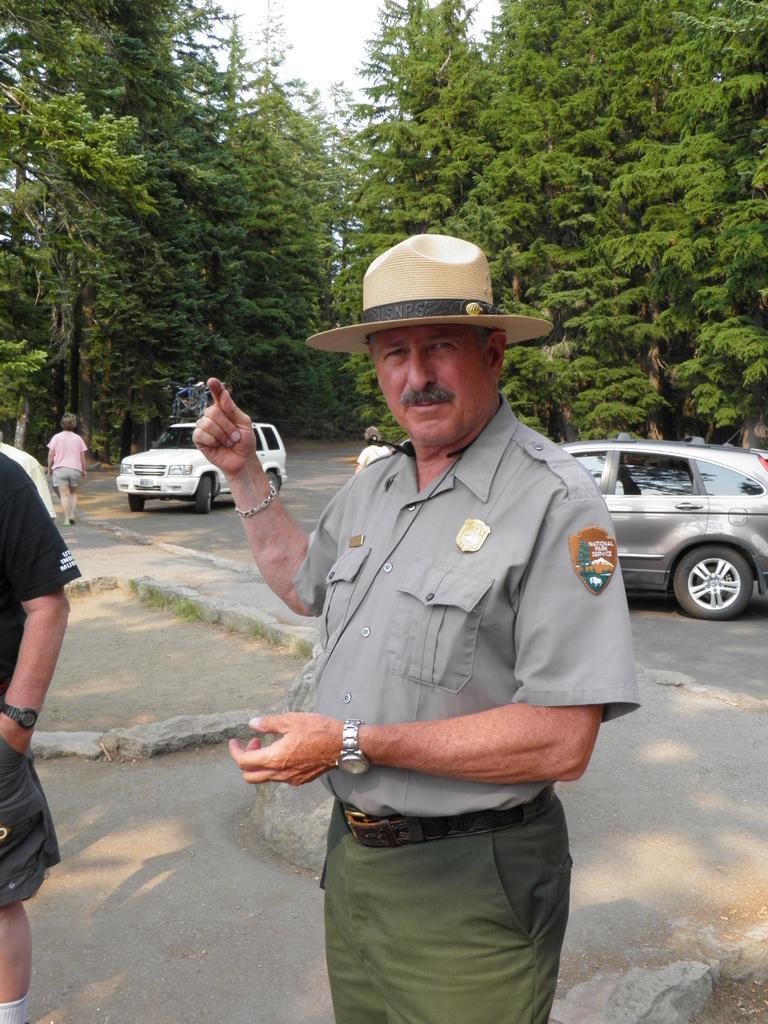Can you describe this image briefly? In this image I can see few people and vehicles on the road. I can see one person wearing the hat. In the background I can see many trees and the sky. 